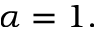Convert formula to latex. <formula><loc_0><loc_0><loc_500><loc_500>\alpha = 1 .</formula> 